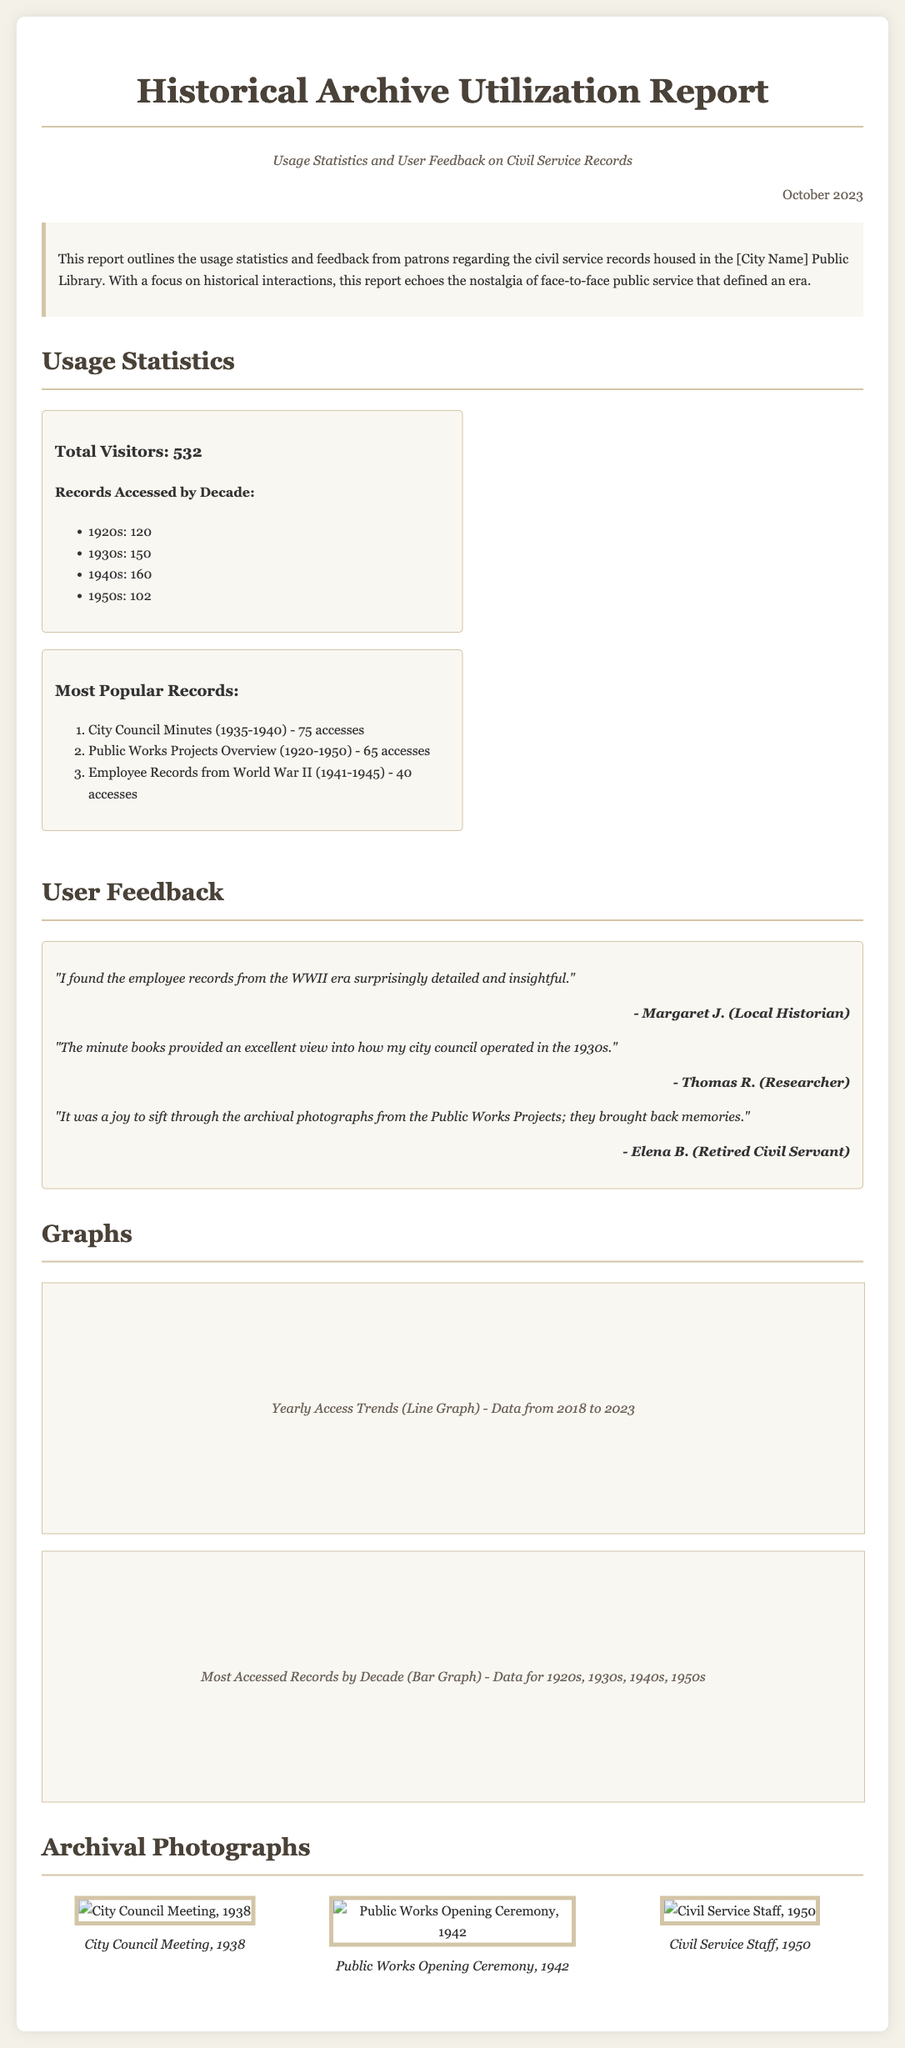What is the total number of visitors? The total number of visitors is explicitly stated in the usage statistics section of the report.
Answer: 532 Which decade had the highest records accessed? The decade with the highest records accessed is provided in the usage statistics section.
Answer: 1940s What is the most accessed record? The most accessed record is listed in the report and includes details about the number of accesses.
Answer: City Council Minutes (1935-1940) Who provided feedback about the WWII employee records? Feedback is given by patrons highlighting their insights about the records, specifically mentioning the WWII records.
Answer: Margaret J How many total accesses were there for the 1920s records? The document lists the number of records accessed by decade, specifically for the 1920s.
Answer: 120 What type of graph is mentioned for yearly access trends? The document describes the type of graph used to depict yearly access trends.
Answer: Line Graph What year is noted for the City Council Meeting photograph? The year for the City Council Meeting photograph is presented with the image in the archival section.
Answer: 1938 How many accesses did the Public Works Projects Overview receive? The report provides specific access numbers for popular records, including this particular overview.
Answer: 65 